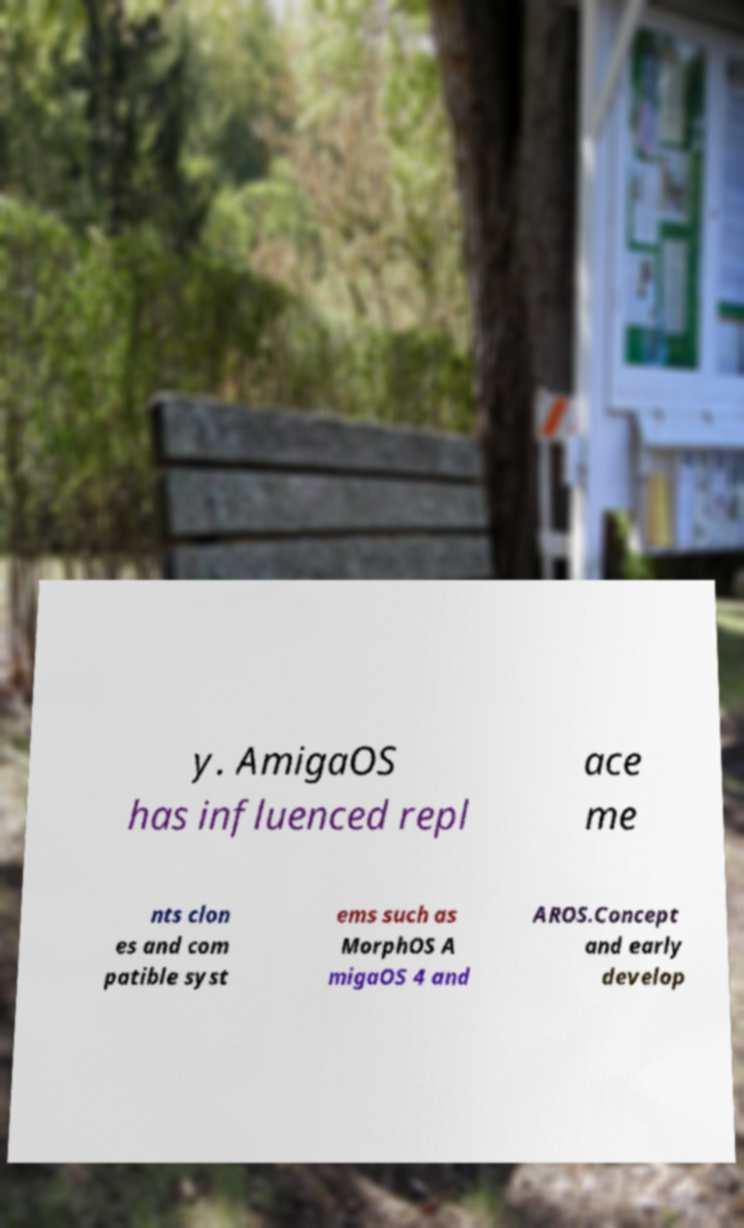Can you read and provide the text displayed in the image?This photo seems to have some interesting text. Can you extract and type it out for me? y. AmigaOS has influenced repl ace me nts clon es and com patible syst ems such as MorphOS A migaOS 4 and AROS.Concept and early develop 